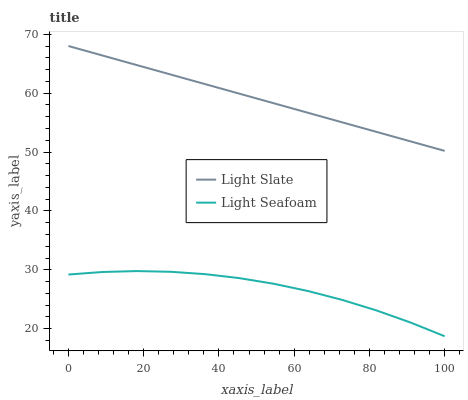Does Light Seafoam have the minimum area under the curve?
Answer yes or no. Yes. Does Light Slate have the maximum area under the curve?
Answer yes or no. Yes. Does Light Seafoam have the maximum area under the curve?
Answer yes or no. No. Is Light Slate the smoothest?
Answer yes or no. Yes. Is Light Seafoam the roughest?
Answer yes or no. Yes. Is Light Seafoam the smoothest?
Answer yes or no. No. Does Light Seafoam have the highest value?
Answer yes or no. No. Is Light Seafoam less than Light Slate?
Answer yes or no. Yes. Is Light Slate greater than Light Seafoam?
Answer yes or no. Yes. Does Light Seafoam intersect Light Slate?
Answer yes or no. No. 